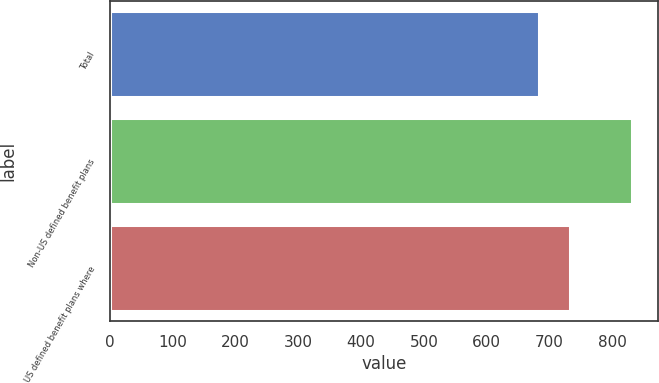Convert chart to OTSL. <chart><loc_0><loc_0><loc_500><loc_500><bar_chart><fcel>Total<fcel>Non-US defined benefit plans<fcel>US defined benefit plans where<nl><fcel>682.6<fcel>832<fcel>733.2<nl></chart> 